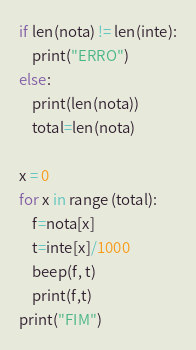Convert code to text. <code><loc_0><loc_0><loc_500><loc_500><_Python_>
if len(nota) != len(inte):
    print("ERRO")
else:
    print(len(nota))
    total=len(nota)

x = 0
for x in range (total):
    f=nota[x]
    t=inte[x]/1000
    beep(f, t)
    print(f,t)
print("FIM")
</code> 